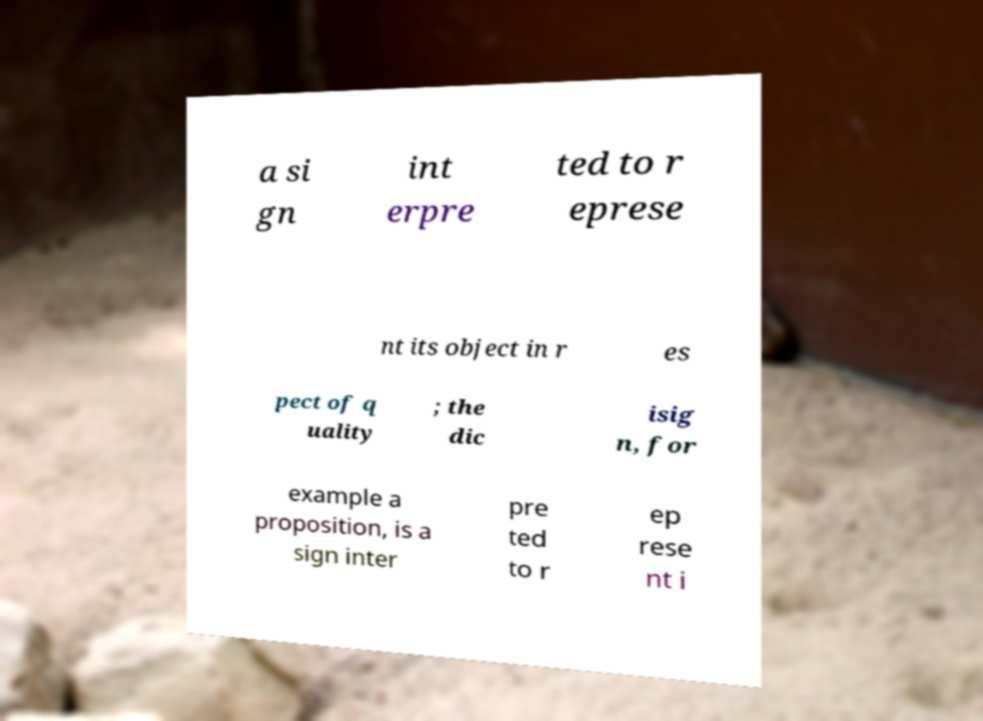What messages or text are displayed in this image? I need them in a readable, typed format. a si gn int erpre ted to r eprese nt its object in r es pect of q uality ; the dic isig n, for example a proposition, is a sign inter pre ted to r ep rese nt i 